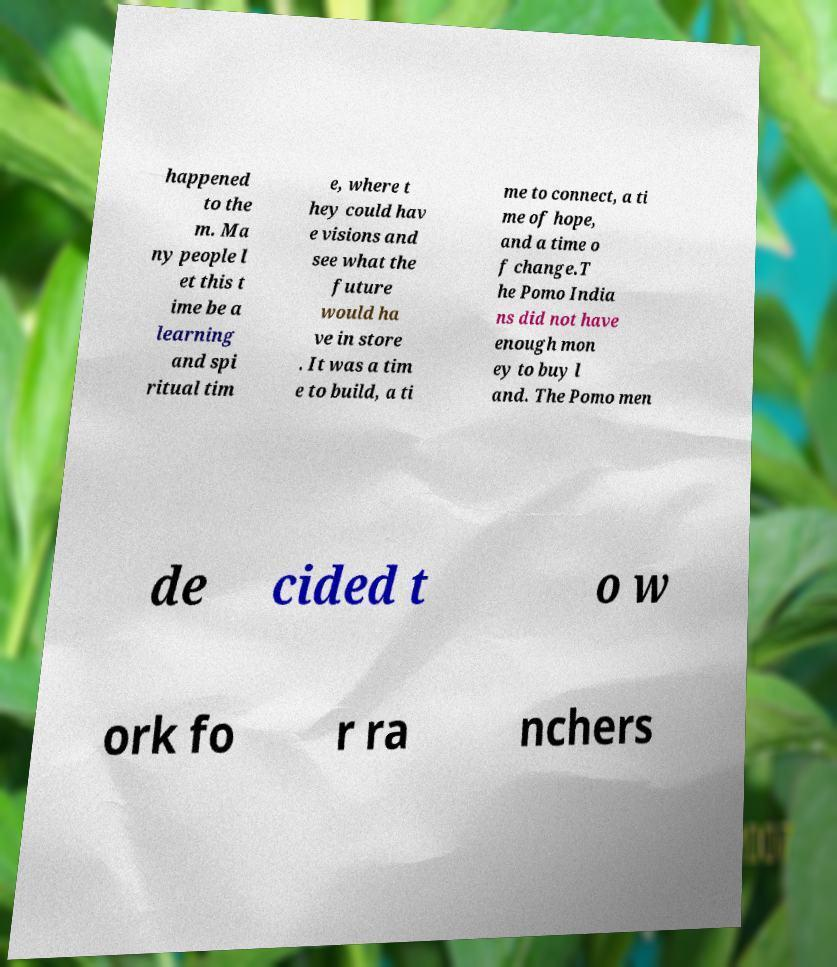For documentation purposes, I need the text within this image transcribed. Could you provide that? happened to the m. Ma ny people l et this t ime be a learning and spi ritual tim e, where t hey could hav e visions and see what the future would ha ve in store . It was a tim e to build, a ti me to connect, a ti me of hope, and a time o f change.T he Pomo India ns did not have enough mon ey to buy l and. The Pomo men de cided t o w ork fo r ra nchers 